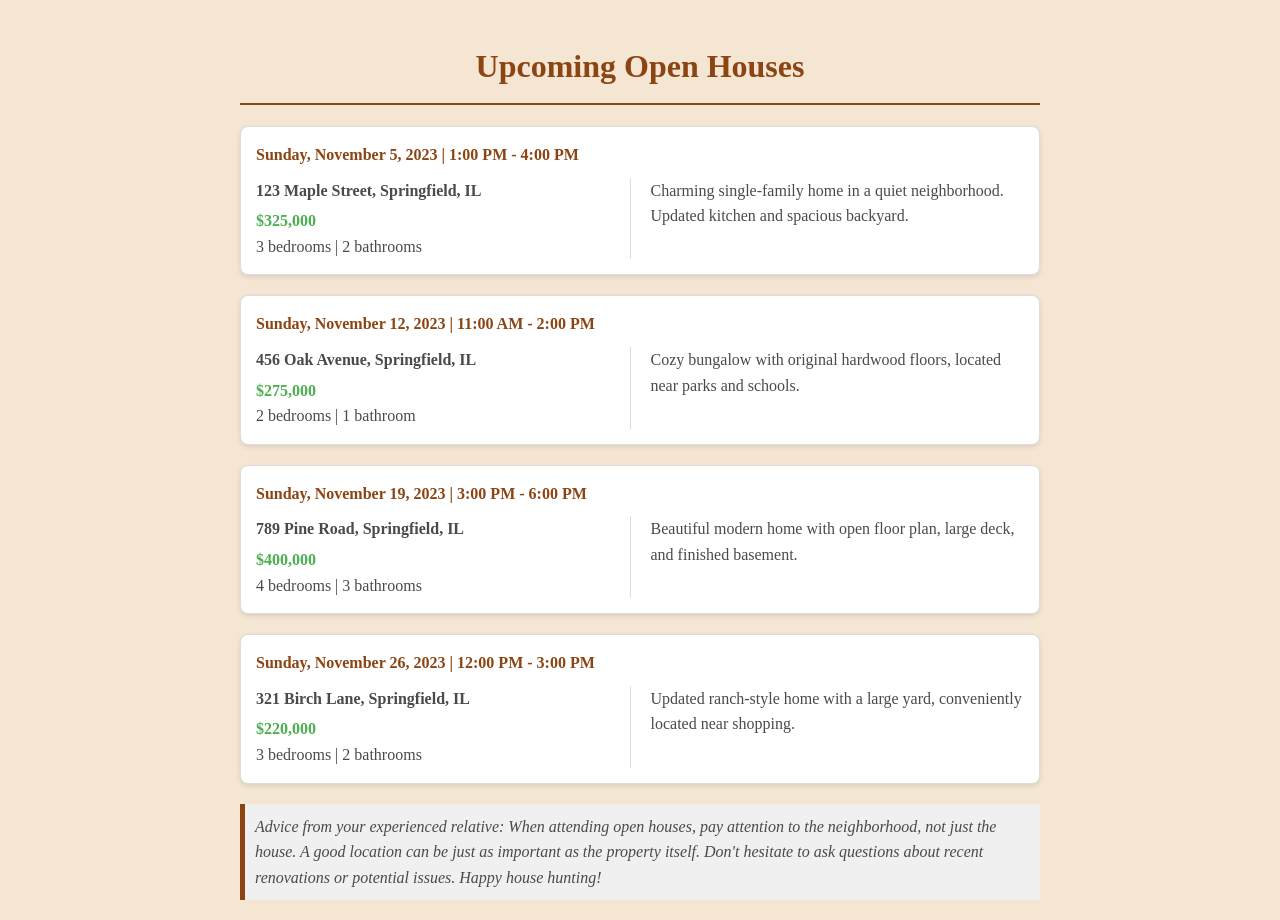What is the address of the first open house? The document lists the first open house at 123 Maple Street, Springfield, IL.
Answer: 123 Maple Street, Springfield, IL How much is the property at 456 Oak Avenue? The document indicates that the property at 456 Oak Avenue is priced at $275,000.
Answer: $275,000 What day is the open house at 789 Pine Road? The date for the open house at 789 Pine Road is listed as Sunday, November 19, 2023.
Answer: Sunday, November 19, 2023 How many bedrooms does the last property have? The last property, located at 321 Birch Lane, has 3 bedrooms as per the document.
Answer: 3 bedrooms What is the time for the open house on November 26, 2023? The timely information for the open house on November 26, 2023, is noted as 12:00 PM - 3:00 PM.
Answer: 12:00 PM - 3:00 PM Which property has a finished basement? The information shows that the property at 789 Pine Road features a finished basement.
Answer: 789 Pine Road How many bathrooms does the property at 123 Maple Street have? According to the document, the property at 123 Maple Street has 2 bathrooms.
Answer: 2 bathrooms What advice is provided regarding attending open houses? The advice suggests to pay attention to the neighborhood when attending open houses.
Answer: Pay attention to the neighborhood What type of home is at 456 Oak Avenue? The document describes the home at 456 Oak Avenue as a cozy bungalow.
Answer: Cozy bungalow 